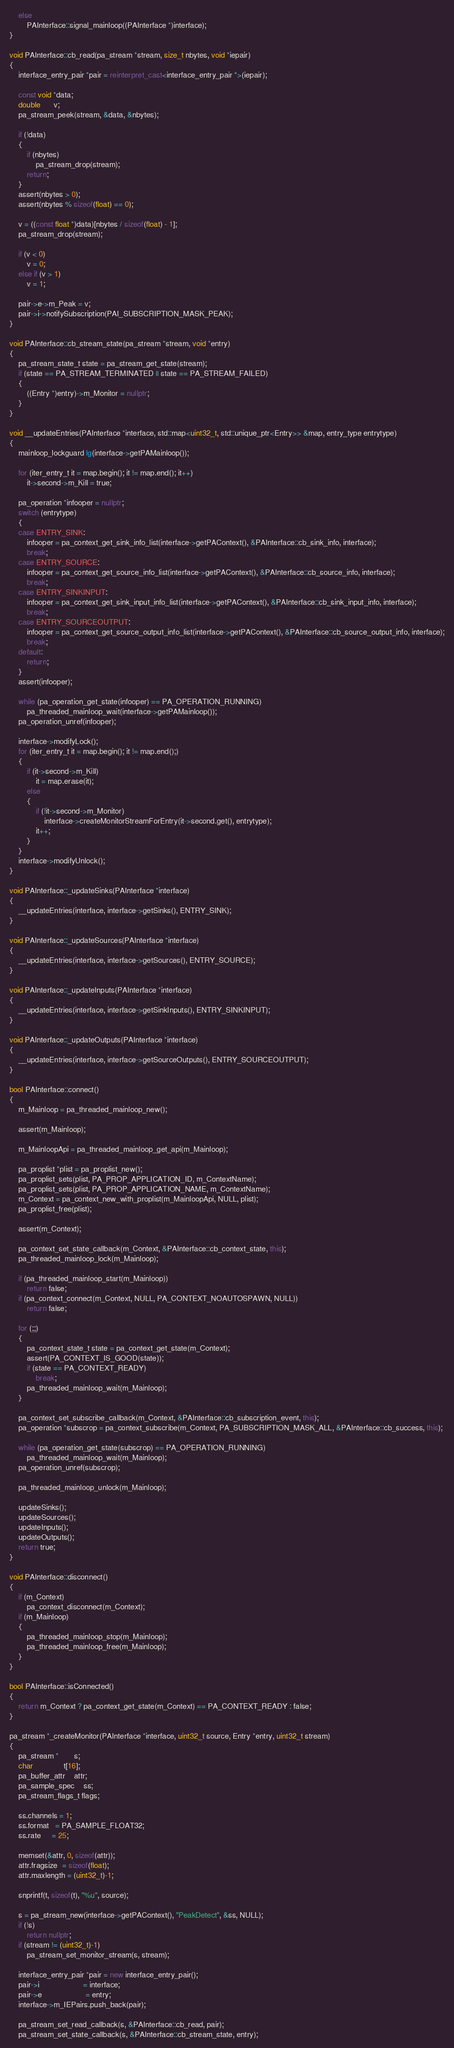Convert code to text. <code><loc_0><loc_0><loc_500><loc_500><_C++_>	else
		PAInterface::signal_mainloop((PAInterface *)interface);
}

void PAInterface::cb_read(pa_stream *stream, size_t nbytes, void *iepair)
{
	interface_entry_pair *pair = reinterpret_cast<interface_entry_pair *>(iepair);

	const void *data;
	double      v;
	pa_stream_peek(stream, &data, &nbytes);

	if (!data)
	{
		if (nbytes)
			pa_stream_drop(stream);
		return;
	}
	assert(nbytes > 0);
	assert(nbytes % sizeof(float) == 0);

	v = ((const float *)data)[nbytes / sizeof(float) - 1];
	pa_stream_drop(stream);

	if (v < 0)
		v = 0;
	else if (v > 1)
		v = 1;

	pair->e->m_Peak = v;
	pair->i->notifySubscription(PAI_SUBSCRIPTION_MASK_PEAK);
}

void PAInterface::cb_stream_state(pa_stream *stream, void *entry)
{
	pa_stream_state_t state = pa_stream_get_state(stream);
	if (state == PA_STREAM_TERMINATED || state == PA_STREAM_FAILED)
	{
		((Entry *)entry)->m_Monitor = nullptr;
	}
}

void __updateEntries(PAInterface *interface, std::map<uint32_t, std::unique_ptr<Entry>> &map, entry_type entrytype)
{
	mainloop_lockguard lg(interface->getPAMainloop());

	for (iter_entry_t it = map.begin(); it != map.end(); it++)
		it->second->m_Kill = true;

	pa_operation *infooper = nullptr;
	switch (entrytype)
	{
	case ENTRY_SINK:
		infooper = pa_context_get_sink_info_list(interface->getPAContext(), &PAInterface::cb_sink_info, interface);
		break;
	case ENTRY_SOURCE:
		infooper = pa_context_get_source_info_list(interface->getPAContext(), &PAInterface::cb_source_info, interface);
		break;
	case ENTRY_SINKINPUT:
		infooper = pa_context_get_sink_input_info_list(interface->getPAContext(), &PAInterface::cb_sink_input_info, interface);
		break;
	case ENTRY_SOURCEOUTPUT:
		infooper = pa_context_get_source_output_info_list(interface->getPAContext(), &PAInterface::cb_source_output_info, interface);
		break;
	default:
		return;
	}
	assert(infooper);

	while (pa_operation_get_state(infooper) == PA_OPERATION_RUNNING)
		pa_threaded_mainloop_wait(interface->getPAMainloop());
	pa_operation_unref(infooper);

	interface->modifyLock();
	for (iter_entry_t it = map.begin(); it != map.end();)
	{
		if (it->second->m_Kill)
			it = map.erase(it);
		else
		{
			if (!it->second->m_Monitor)
				interface->createMonitorStreamForEntry(it->second.get(), entrytype);
			it++;
		}
	}
	interface->modifyUnlock();
}

void PAInterface::_updateSinks(PAInterface *interface)
{
	__updateEntries(interface, interface->getSinks(), ENTRY_SINK);
}

void PAInterface::_updateSources(PAInterface *interface)
{
	__updateEntries(interface, interface->getSources(), ENTRY_SOURCE);
}

void PAInterface::_updateInputs(PAInterface *interface)
{
	__updateEntries(interface, interface->getSinkInputs(), ENTRY_SINKINPUT);
}

void PAInterface::_updateOutputs(PAInterface *interface)
{
	__updateEntries(interface, interface->getSourceOutputs(), ENTRY_SOURCEOUTPUT);
}

bool PAInterface::connect()
{
	m_Mainloop = pa_threaded_mainloop_new();

	assert(m_Mainloop);

	m_MainloopApi = pa_threaded_mainloop_get_api(m_Mainloop);

	pa_proplist *plist = pa_proplist_new();
	pa_proplist_sets(plist, PA_PROP_APPLICATION_ID, m_ContextName);
	pa_proplist_sets(plist, PA_PROP_APPLICATION_NAME, m_ContextName);
	m_Context = pa_context_new_with_proplist(m_MainloopApi, NULL, plist);
	pa_proplist_free(plist);

	assert(m_Context);

	pa_context_set_state_callback(m_Context, &PAInterface::cb_context_state, this);
	pa_threaded_mainloop_lock(m_Mainloop);

	if (pa_threaded_mainloop_start(m_Mainloop))
		return false;
	if (pa_context_connect(m_Context, NULL, PA_CONTEXT_NOAUTOSPAWN, NULL))
		return false;

	for (;;)
	{
		pa_context_state_t state = pa_context_get_state(m_Context);
		assert(PA_CONTEXT_IS_GOOD(state));
		if (state == PA_CONTEXT_READY)
			break;
		pa_threaded_mainloop_wait(m_Mainloop);
	}

	pa_context_set_subscribe_callback(m_Context, &PAInterface::cb_subscription_event, this);
	pa_operation *subscrop = pa_context_subscribe(m_Context, PA_SUBSCRIPTION_MASK_ALL, &PAInterface::cb_success, this);

	while (pa_operation_get_state(subscrop) == PA_OPERATION_RUNNING)
		pa_threaded_mainloop_wait(m_Mainloop);
	pa_operation_unref(subscrop);

	pa_threaded_mainloop_unlock(m_Mainloop);

	updateSinks();
	updateSources();
	updateInputs();
	updateOutputs();
	return true;
}

void PAInterface::disconnect()
{
	if (m_Context)
		pa_context_disconnect(m_Context);
	if (m_Mainloop)
	{
		pa_threaded_mainloop_stop(m_Mainloop);
		pa_threaded_mainloop_free(m_Mainloop);
	}
}

bool PAInterface::isConnected()
{
	return m_Context ? pa_context_get_state(m_Context) == PA_CONTEXT_READY : false;
}

pa_stream *_createMonitor(PAInterface *interface, uint32_t source, Entry *entry, uint32_t stream)
{
	pa_stream *       s;
	char              t[16];
	pa_buffer_attr    attr;
	pa_sample_spec    ss;
	pa_stream_flags_t flags;

	ss.channels = 1;
	ss.format   = PA_SAMPLE_FLOAT32;
	ss.rate     = 25;

	memset(&attr, 0, sizeof(attr));
	attr.fragsize  = sizeof(float);
	attr.maxlength = (uint32_t)-1;

	snprintf(t, sizeof(t), "%u", source);

	s = pa_stream_new(interface->getPAContext(), "PeakDetect", &ss, NULL);
	if (!s)
		return nullptr;
	if (stream != (uint32_t)-1)
		pa_stream_set_monitor_stream(s, stream);

	interface_entry_pair *pair = new interface_entry_pair();
	pair->i                    = interface;
	pair->e                    = entry;
	interface->m_IEPairs.push_back(pair);

	pa_stream_set_read_callback(s, &PAInterface::cb_read, pair);
	pa_stream_set_state_callback(s, &PAInterface::cb_stream_state, entry);
</code> 